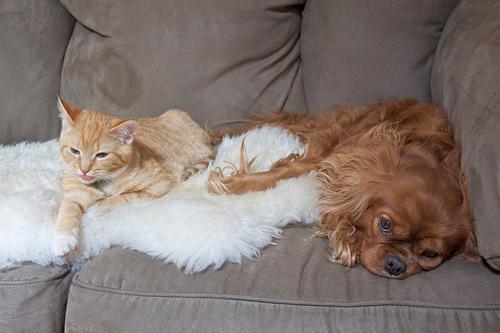How many paws do you see?
Answer briefly. 3. What sound does this animal make?
Concise answer only. Bark. What color is the dog?
Write a very short answer. Brown. Are these animals fighting?
Keep it brief. No. How many animals are alive?
Be succinct. 2. Are these animals work animals or pets?
Concise answer only. Pets. What are the pets laying on?
Be succinct. Couch. What is the cat laying on?
Concise answer only. Blanket. Is this cat lying on the sofa?
Concise answer only. Yes. 